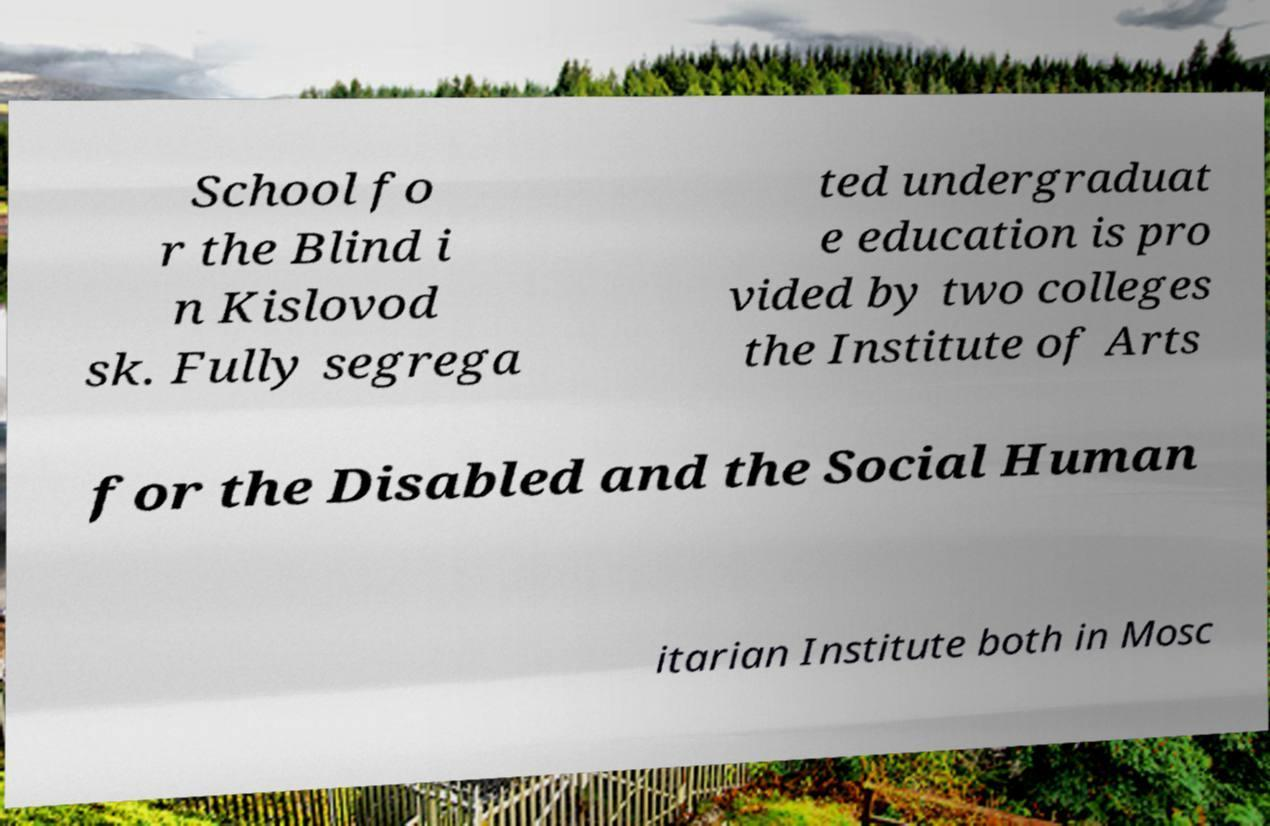Please identify and transcribe the text found in this image. School fo r the Blind i n Kislovod sk. Fully segrega ted undergraduat e education is pro vided by two colleges the Institute of Arts for the Disabled and the Social Human itarian Institute both in Mosc 